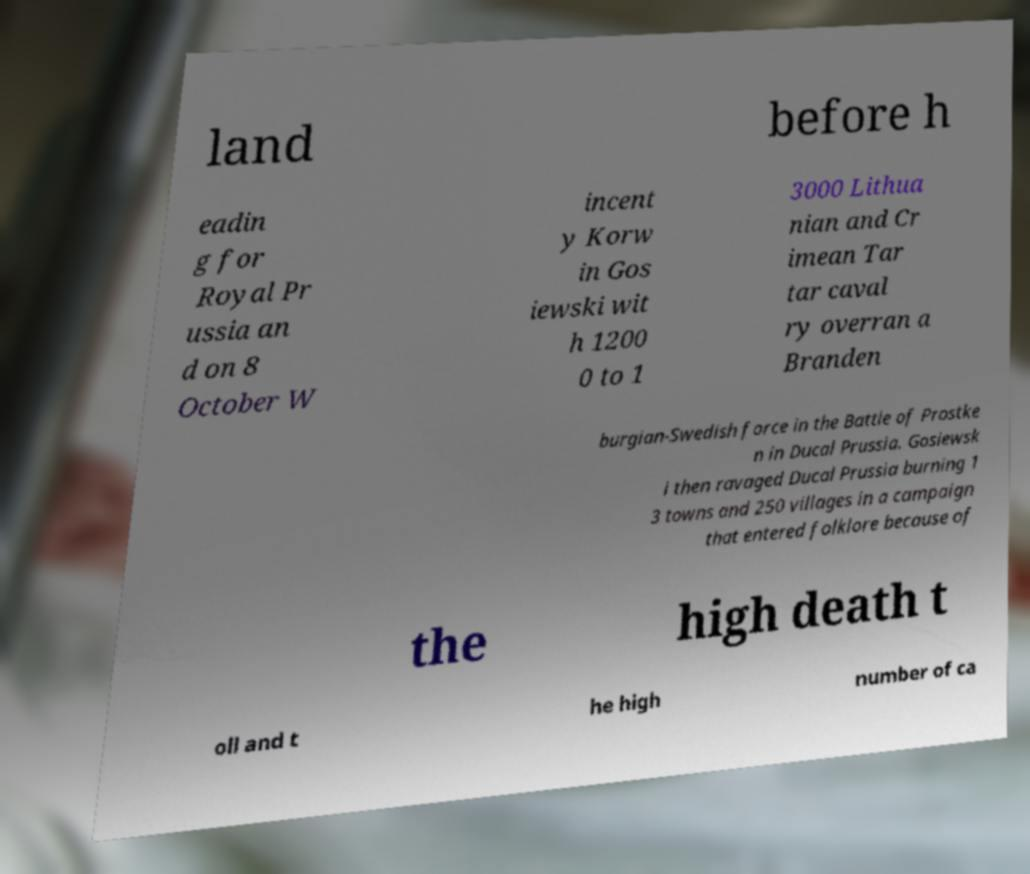There's text embedded in this image that I need extracted. Can you transcribe it verbatim? land before h eadin g for Royal Pr ussia an d on 8 October W incent y Korw in Gos iewski wit h 1200 0 to 1 3000 Lithua nian and Cr imean Tar tar caval ry overran a Branden burgian-Swedish force in the Battle of Prostke n in Ducal Prussia. Gosiewsk i then ravaged Ducal Prussia burning 1 3 towns and 250 villages in a campaign that entered folklore because of the high death t oll and t he high number of ca 